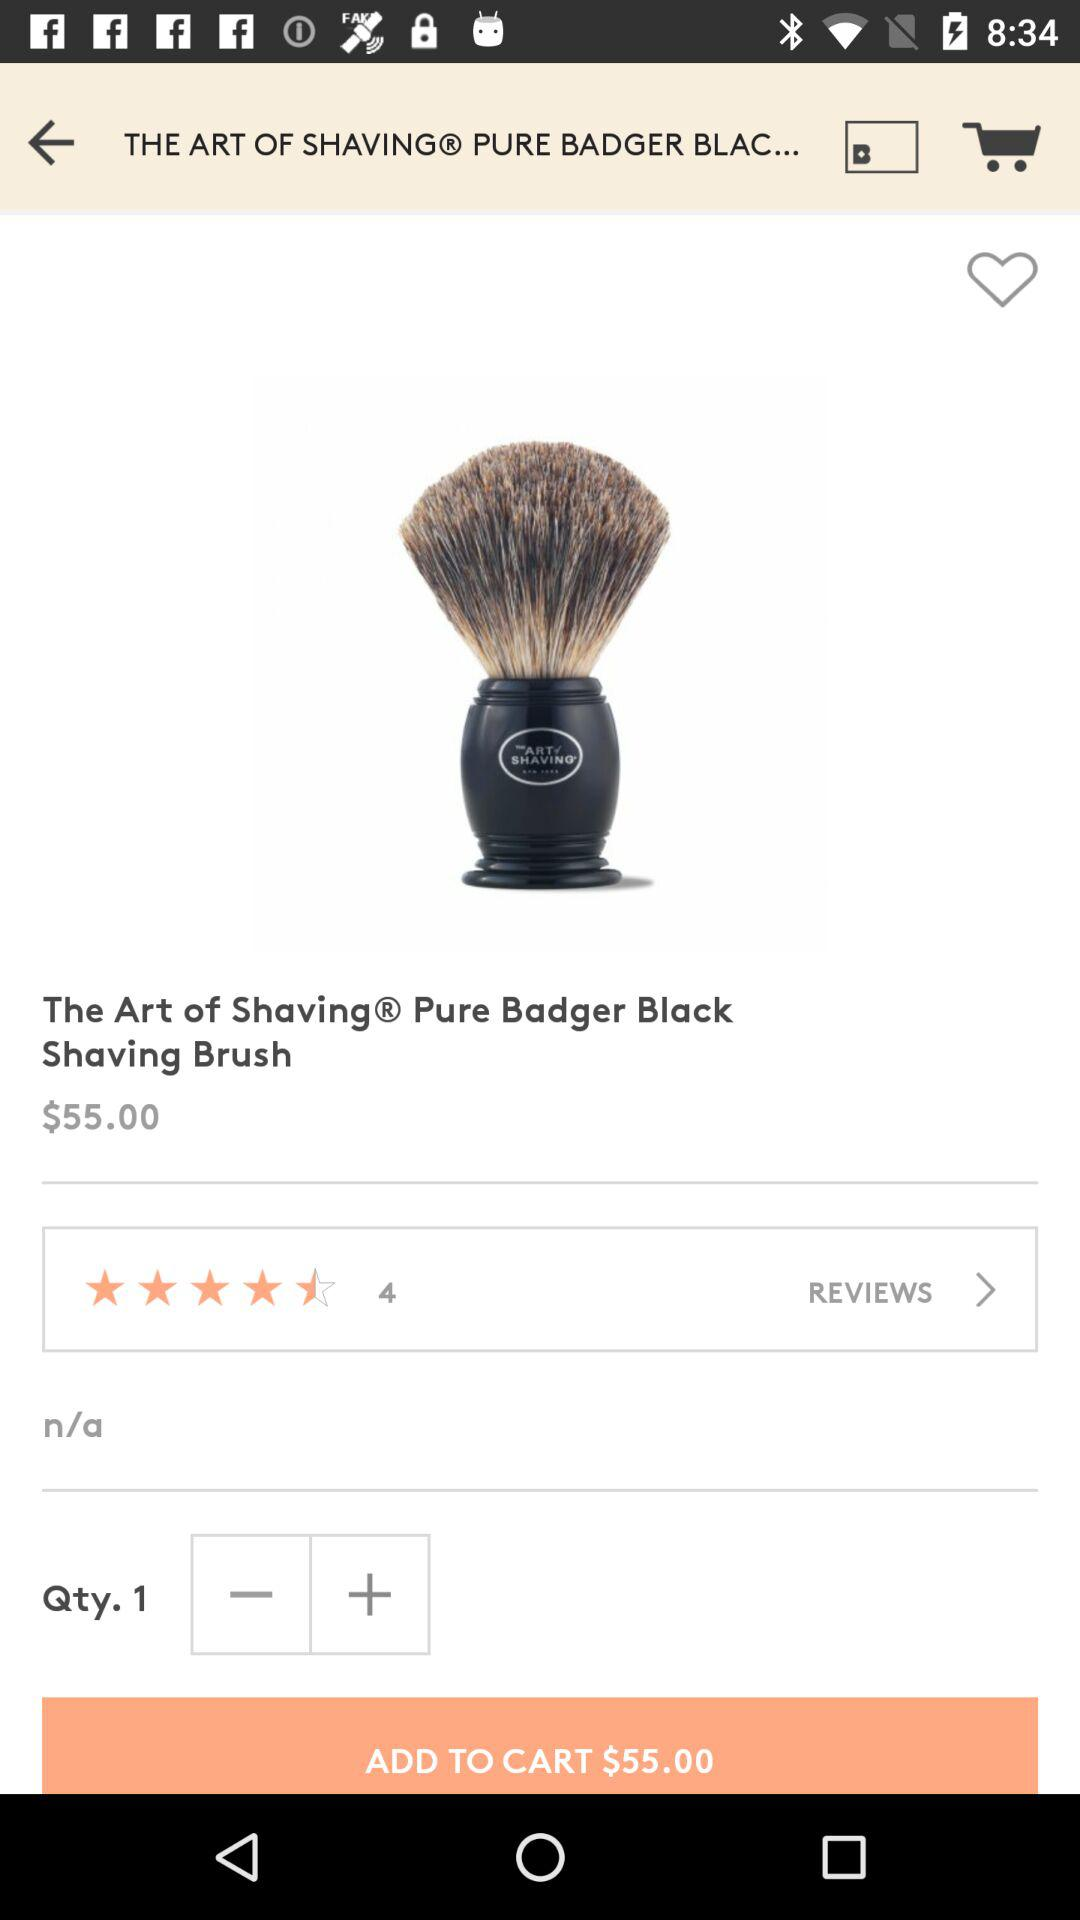What is the given rating for the item? The given rating for the item is 4.5 stars. 